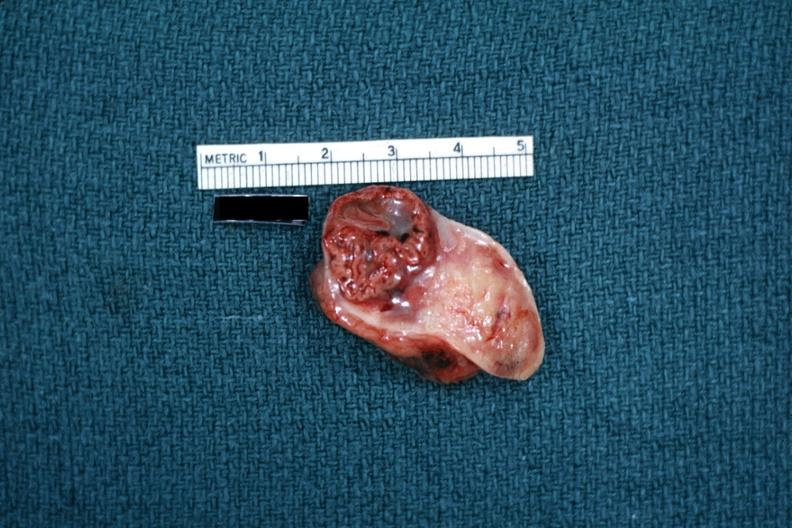what is present?
Answer the question using a single word or phrase. Female reproductive 